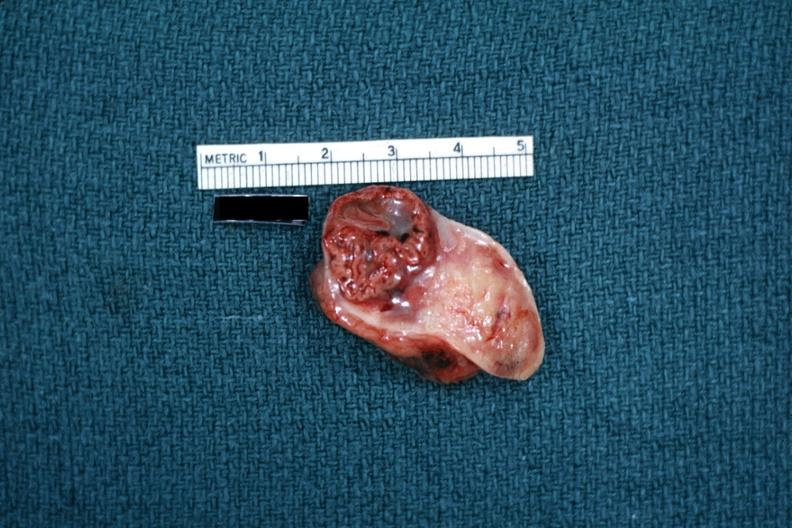what is present?
Answer the question using a single word or phrase. Female reproductive 